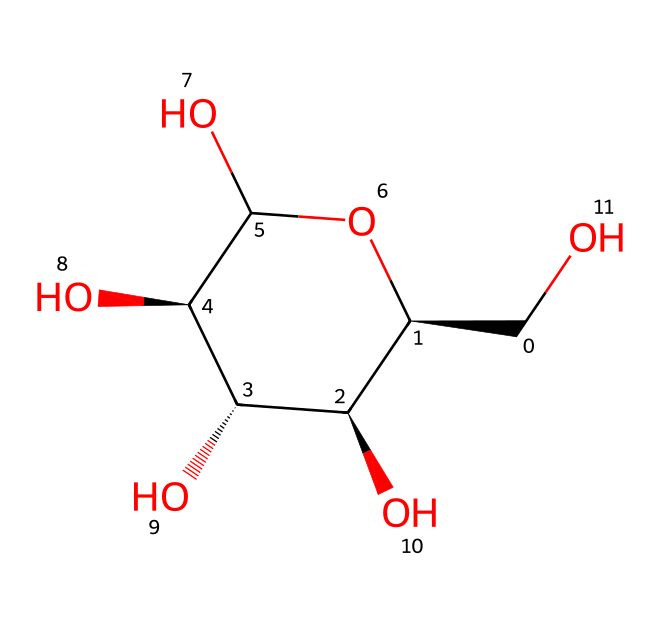What is the molecular formula of glucose? To determine the molecular formula from the SMILES representation, we can count the number of carbon (C), hydrogen (H), and oxygen (O) atoms present. The structure shows 6 carbon atoms, 12 hydrogen atoms, and 6 oxygen atoms, leading to the formula C6H12O6.
Answer: C6H12O6 How many chiral centers are in glucose? The structure reveals the presence of four carbon atoms that are attached to four different groups, indicating the presence of chiral centers. Therefore, glucose has four chiral centers.
Answer: four What type of carbohydrate is glucose? Glucose is classified as a monosaccharide as it is a simple sugar comprising a single sugar unit. This can be derived from its structure, which does not consist of multiple sugar units linked by glycosidic bonds.
Answer: monosaccharide What functional groups are present in glucose? Analyzing the structure, glucose contains multiple hydroxyl (-OH) groups. These are evident from the 'O' atoms surrounding the carbon skeleton, confirming the presence of alcohol functional groups in the molecule.
Answer: hydroxyl groups What is the significance of glucose in energy production? Glucose plays a crucial role in cellular respiration where it is metabolized to produce ATP, the energy currency of the cell. This importance is derived from its structure, which enables efficient breakdown during energy production processes.
Answer: energy currency What kind of stereochemistry does glucose exhibit? Glucose has a configuration of stereoisomers due to its multiple chiral centers, leading to specific spatial arrangements. This structural property indicates that glucose exhibits D- stereochemistry, which is common in naturally occurring sugars.
Answer: D- stereochemistry 